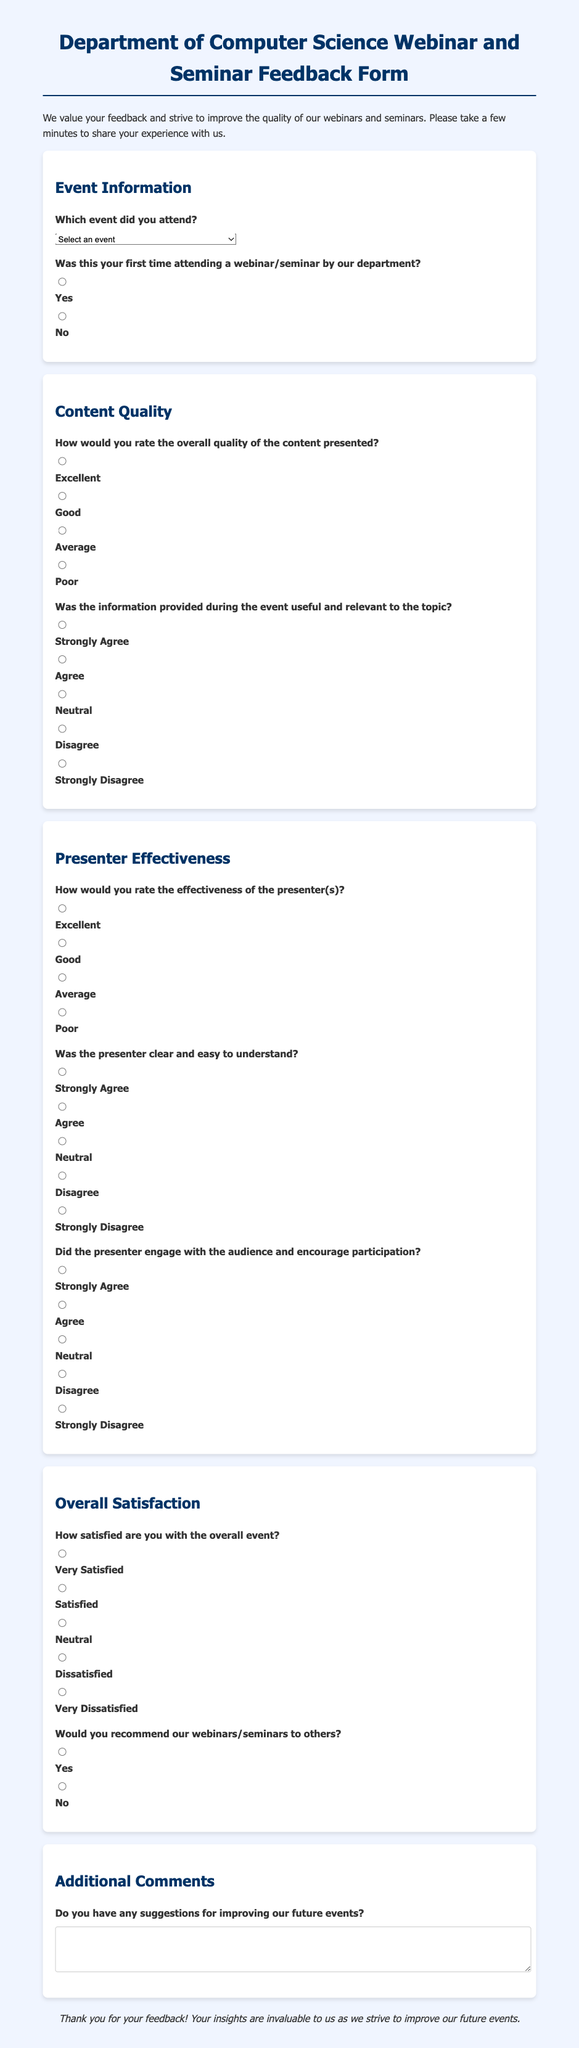What is the title of the feedback form? The title of the feedback form is prominently displayed at the top of the document, indicating the purpose of the form.
Answer: Department of Computer Science Webinar and Seminar Feedback Form What is the date of the AI in Healthcare event? The date for the AI in Healthcare event is listed in the event options, showing the specific date attendees are providing feedback on.
Answer: January 15, 2023 How many options are provided for the content quality rating? The document outlines various rating options under content quality, indicating the level of detail requested from attendees.
Answer: Four Which question assesses the presenter's clarity? The document has a specific question dedicated to evaluating how clear and understandable the presenter was during the event.
Answer: Was the presenter clear and easy to understand? What is the second option for overall event satisfaction? The document provides a range of options for overall satisfaction, allowing participants to express varying levels of satisfaction.
Answer: Satisfied Was the feedback form required for first-time attendees? The document clearly states whether the first-time attendance is a required response for submitting the feedback form.
Answer: Yes 